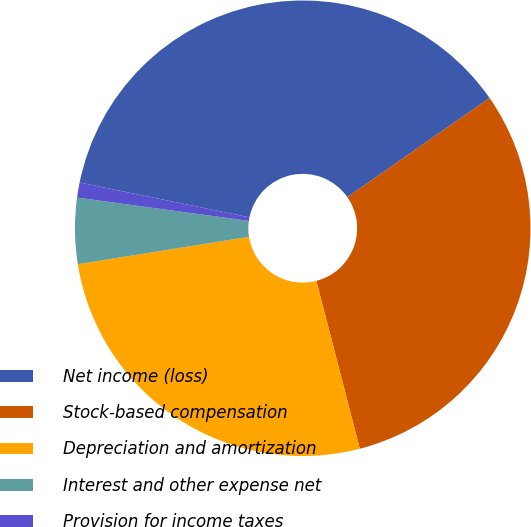<chart> <loc_0><loc_0><loc_500><loc_500><pie_chart><fcel>Net income (loss)<fcel>Stock-based compensation<fcel>Depreciation and amortization<fcel>Interest and other expense net<fcel>Provision for income taxes<nl><fcel>37.09%<fcel>30.66%<fcel>26.51%<fcel>4.67%<fcel>1.07%<nl></chart> 